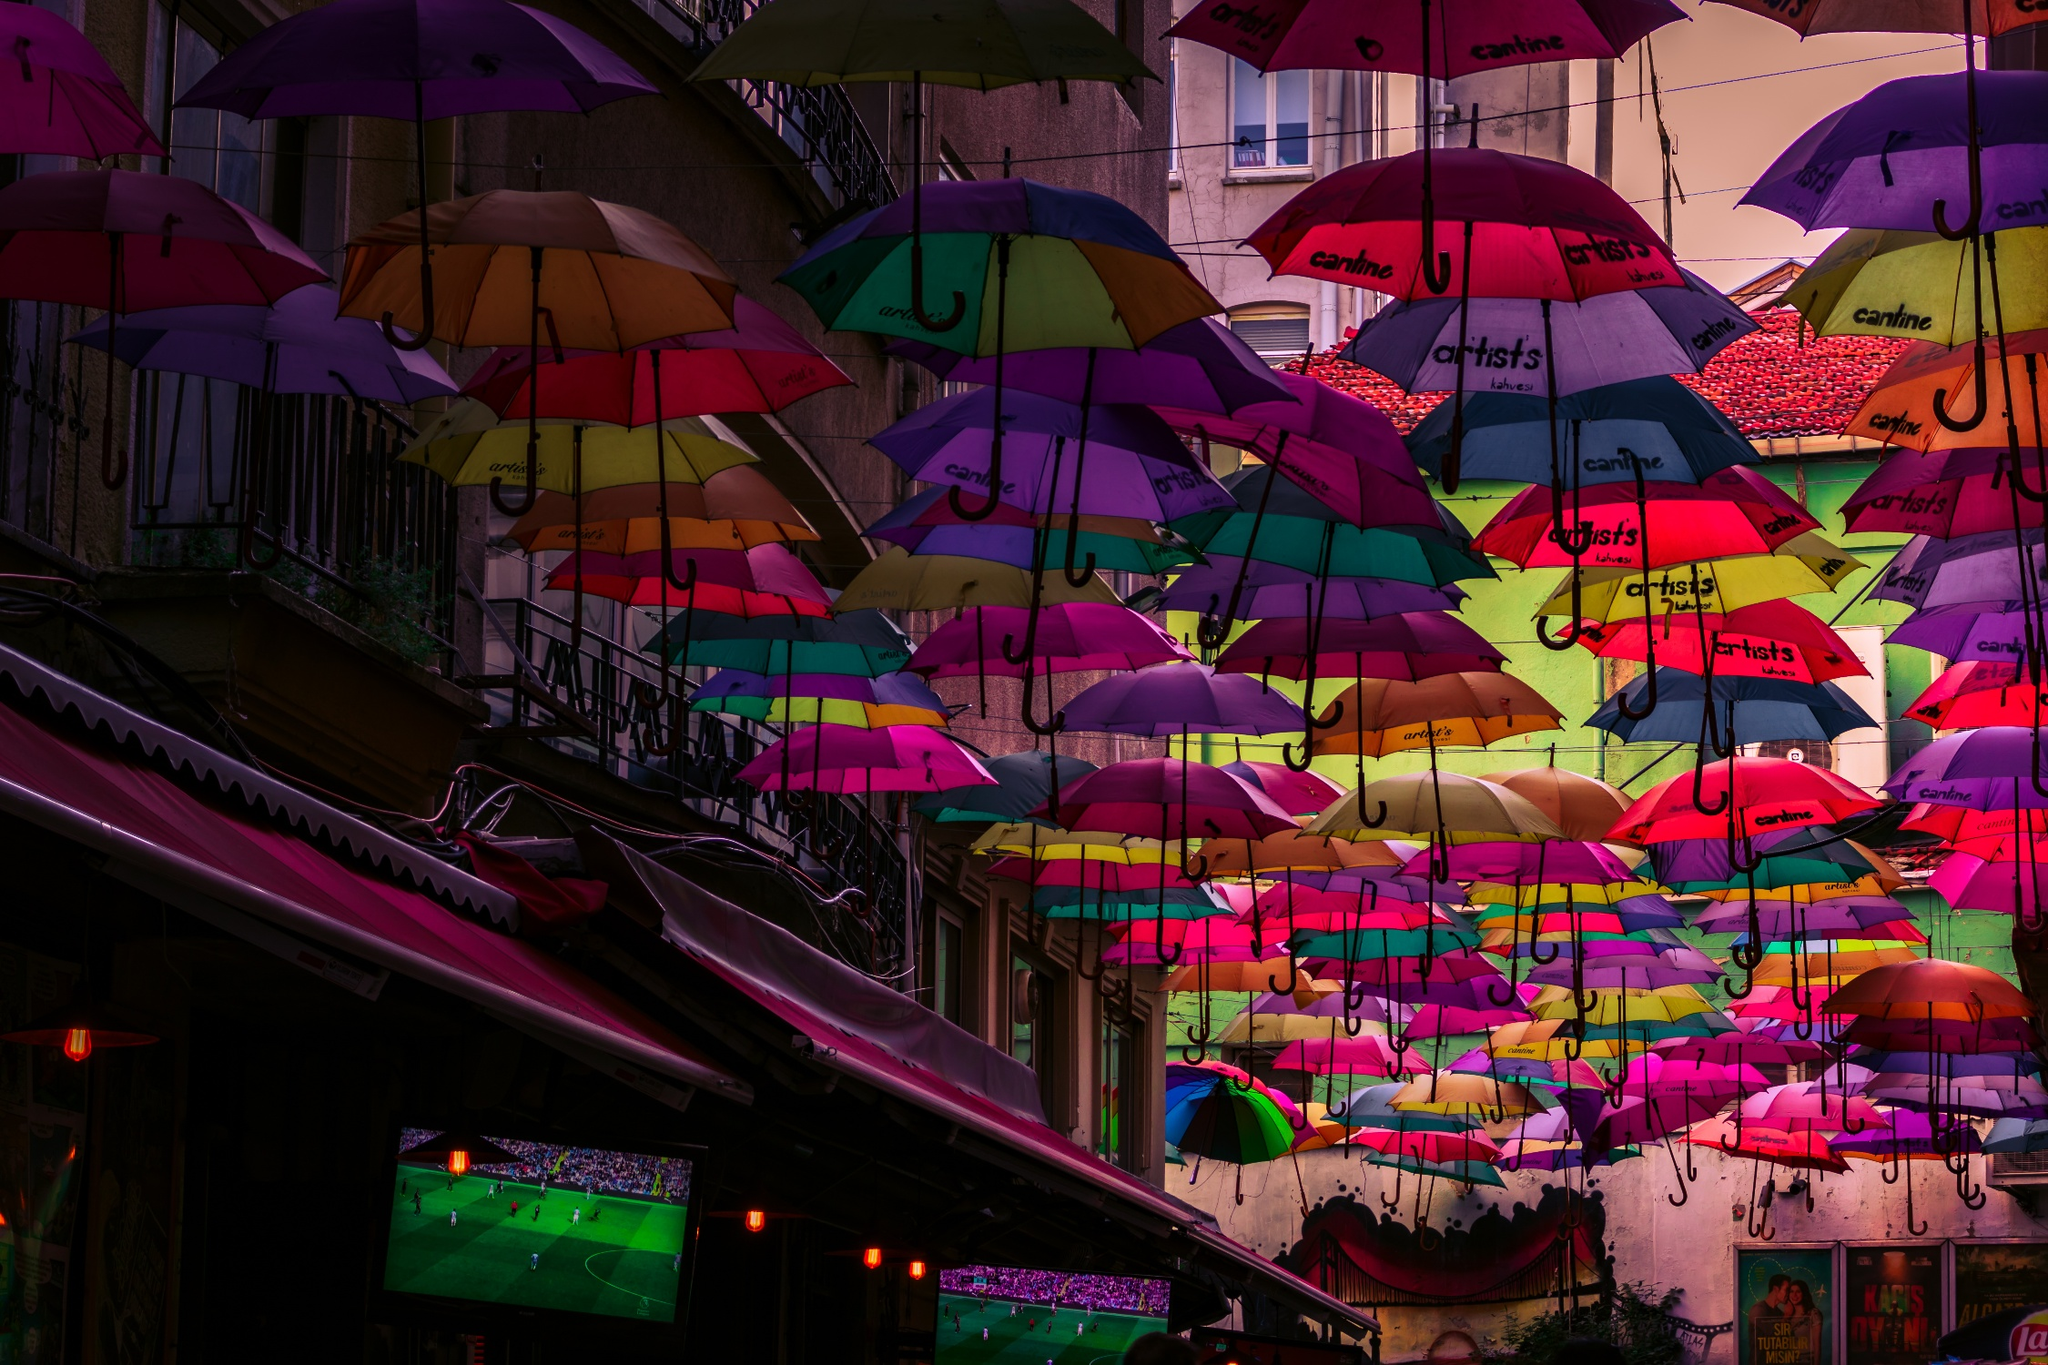Can you explain the cultural significance of using umbrellas in this manner? Umbrellas suspended in such a manner are often part of an art installation or a seasonal festival, particularly in parts of Europe like Portugal. They serve as both aesthetic enhancements and practical shelters, creating a vibrant and immersive atmosphere. This installation can attract tourists and locals alike, fostering a sense of community and celebration in the area. Additionally, they may serve to promote local businesses and cultural events, as suggested by the brand labels on each umbrella. 